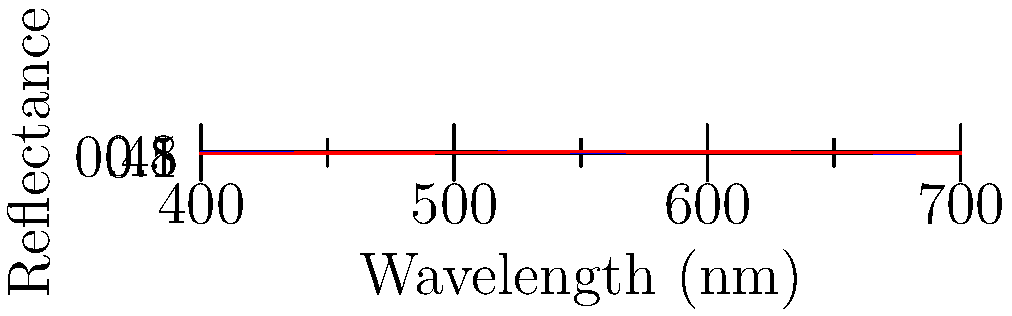Based on the spectral data shown in the graph, which machine learning technique would be most appropriate for predicting skin pH levels, and why? To determine the most appropriate machine learning technique for predicting skin pH levels from spectral data, we need to consider the following steps:

1. Data characteristics:
   - The input features are continuous (wavelengths)
   - The output (pH level) is also continuous
   - There appears to be a non-linear relationship between spectral reflectance and pH

2. Problem type:
   - This is a regression problem, as we're predicting a continuous value (pH)

3. Sample size:
   - Assuming we have a large dataset with many samples, we can consider more complex models

4. Model interpretability:
   - As a dermatology researcher, interpretability might be important for understanding the relationship between spectral data and skin pH

5. Potential techniques:
   a) Support Vector Regression (SVR):
      - Can handle non-linear relationships
      - Works well with high-dimensional data
   b) Random Forest Regression:
      - Can capture complex relationships
      - Provides feature importance
   c) Neural Networks:
      - Can learn complex patterns
      - Requires more data and tuning

Considering these factors, Random Forest Regression would be the most appropriate technique because:
- It can handle non-linear relationships in the data
- It works well with high-dimensional spectral data
- It provides feature importance, which can help identify key wavelengths
- It's less prone to overfitting compared to neural networks
- It offers a good balance between predictive power and interpretability
Answer: Random Forest Regression 